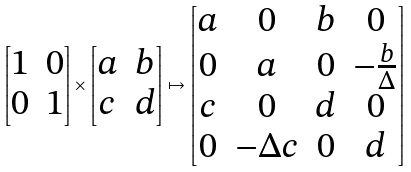Convert formula to latex. <formula><loc_0><loc_0><loc_500><loc_500>\begin{bmatrix} 1 & 0 \\ 0 & 1 \end{bmatrix} \times \begin{bmatrix} a & b \\ c & d \end{bmatrix} \mapsto \begin{bmatrix} a & 0 & b & 0 \\ 0 & a & 0 & - \frac { b } { \Delta } \\ c & 0 & d & 0 \\ 0 & - \Delta c & 0 & d \end{bmatrix}</formula> 